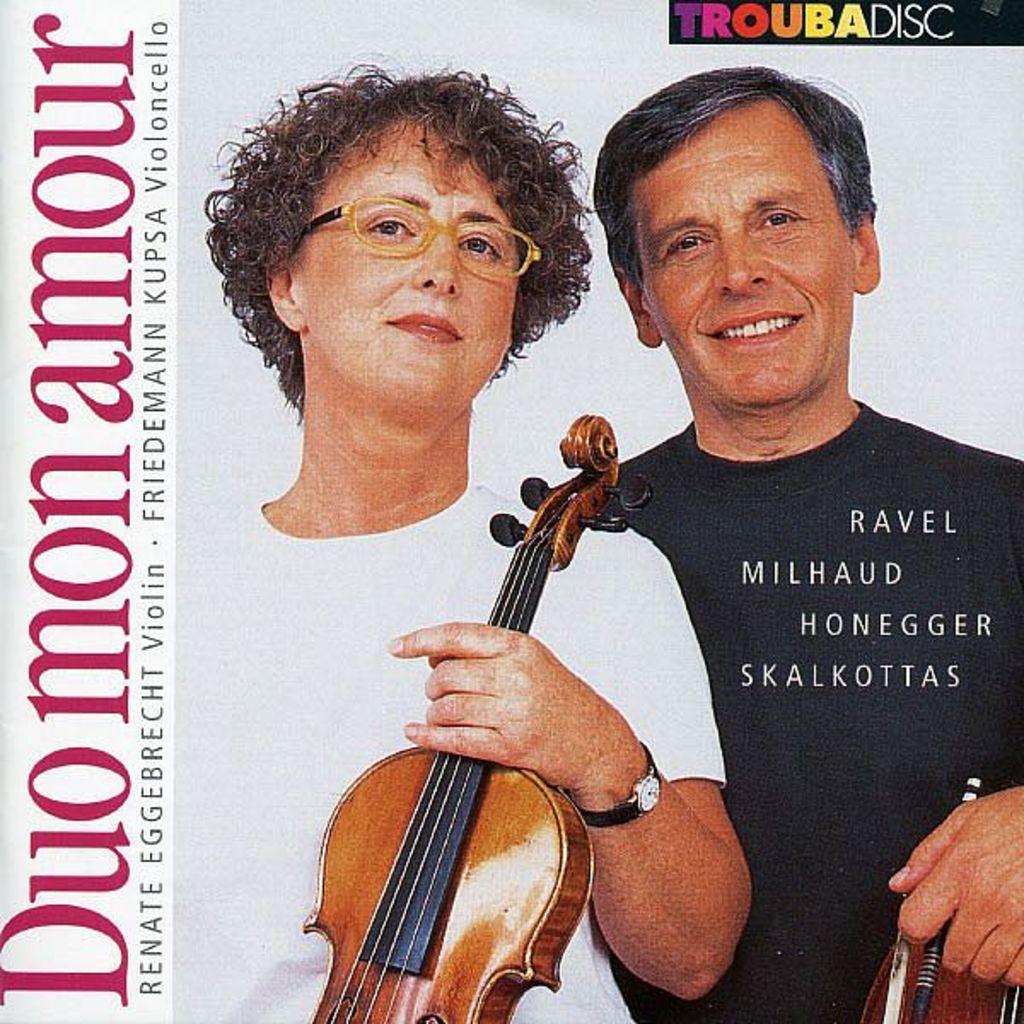Please provide a concise description of this image. In this image I can see a banner. On the banner there are two people holding the guitar. 